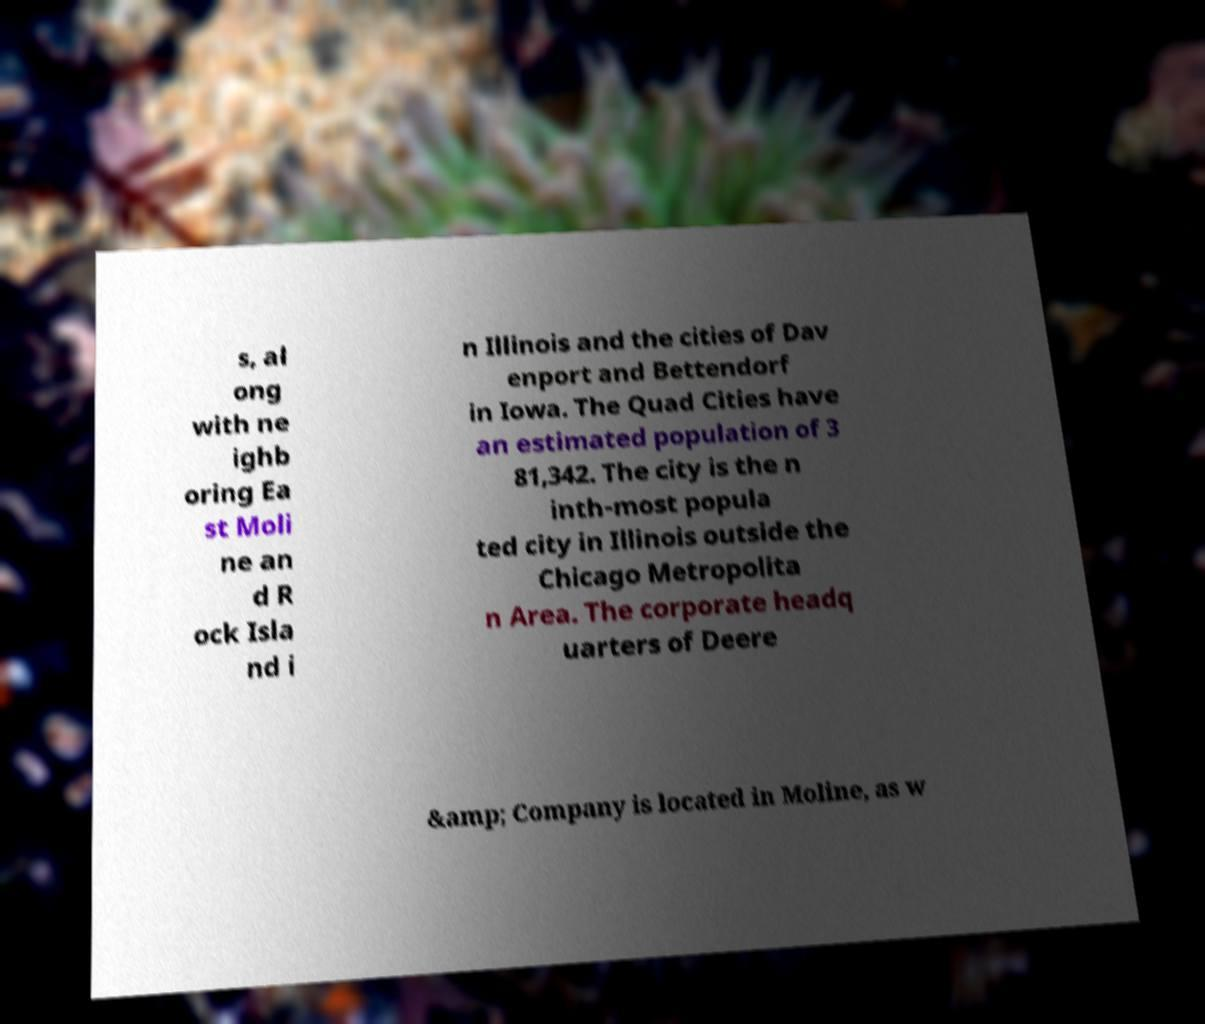Please identify and transcribe the text found in this image. s, al ong with ne ighb oring Ea st Moli ne an d R ock Isla nd i n Illinois and the cities of Dav enport and Bettendorf in Iowa. The Quad Cities have an estimated population of 3 81,342. The city is the n inth-most popula ted city in Illinois outside the Chicago Metropolita n Area. The corporate headq uarters of Deere &amp; Company is located in Moline, as w 